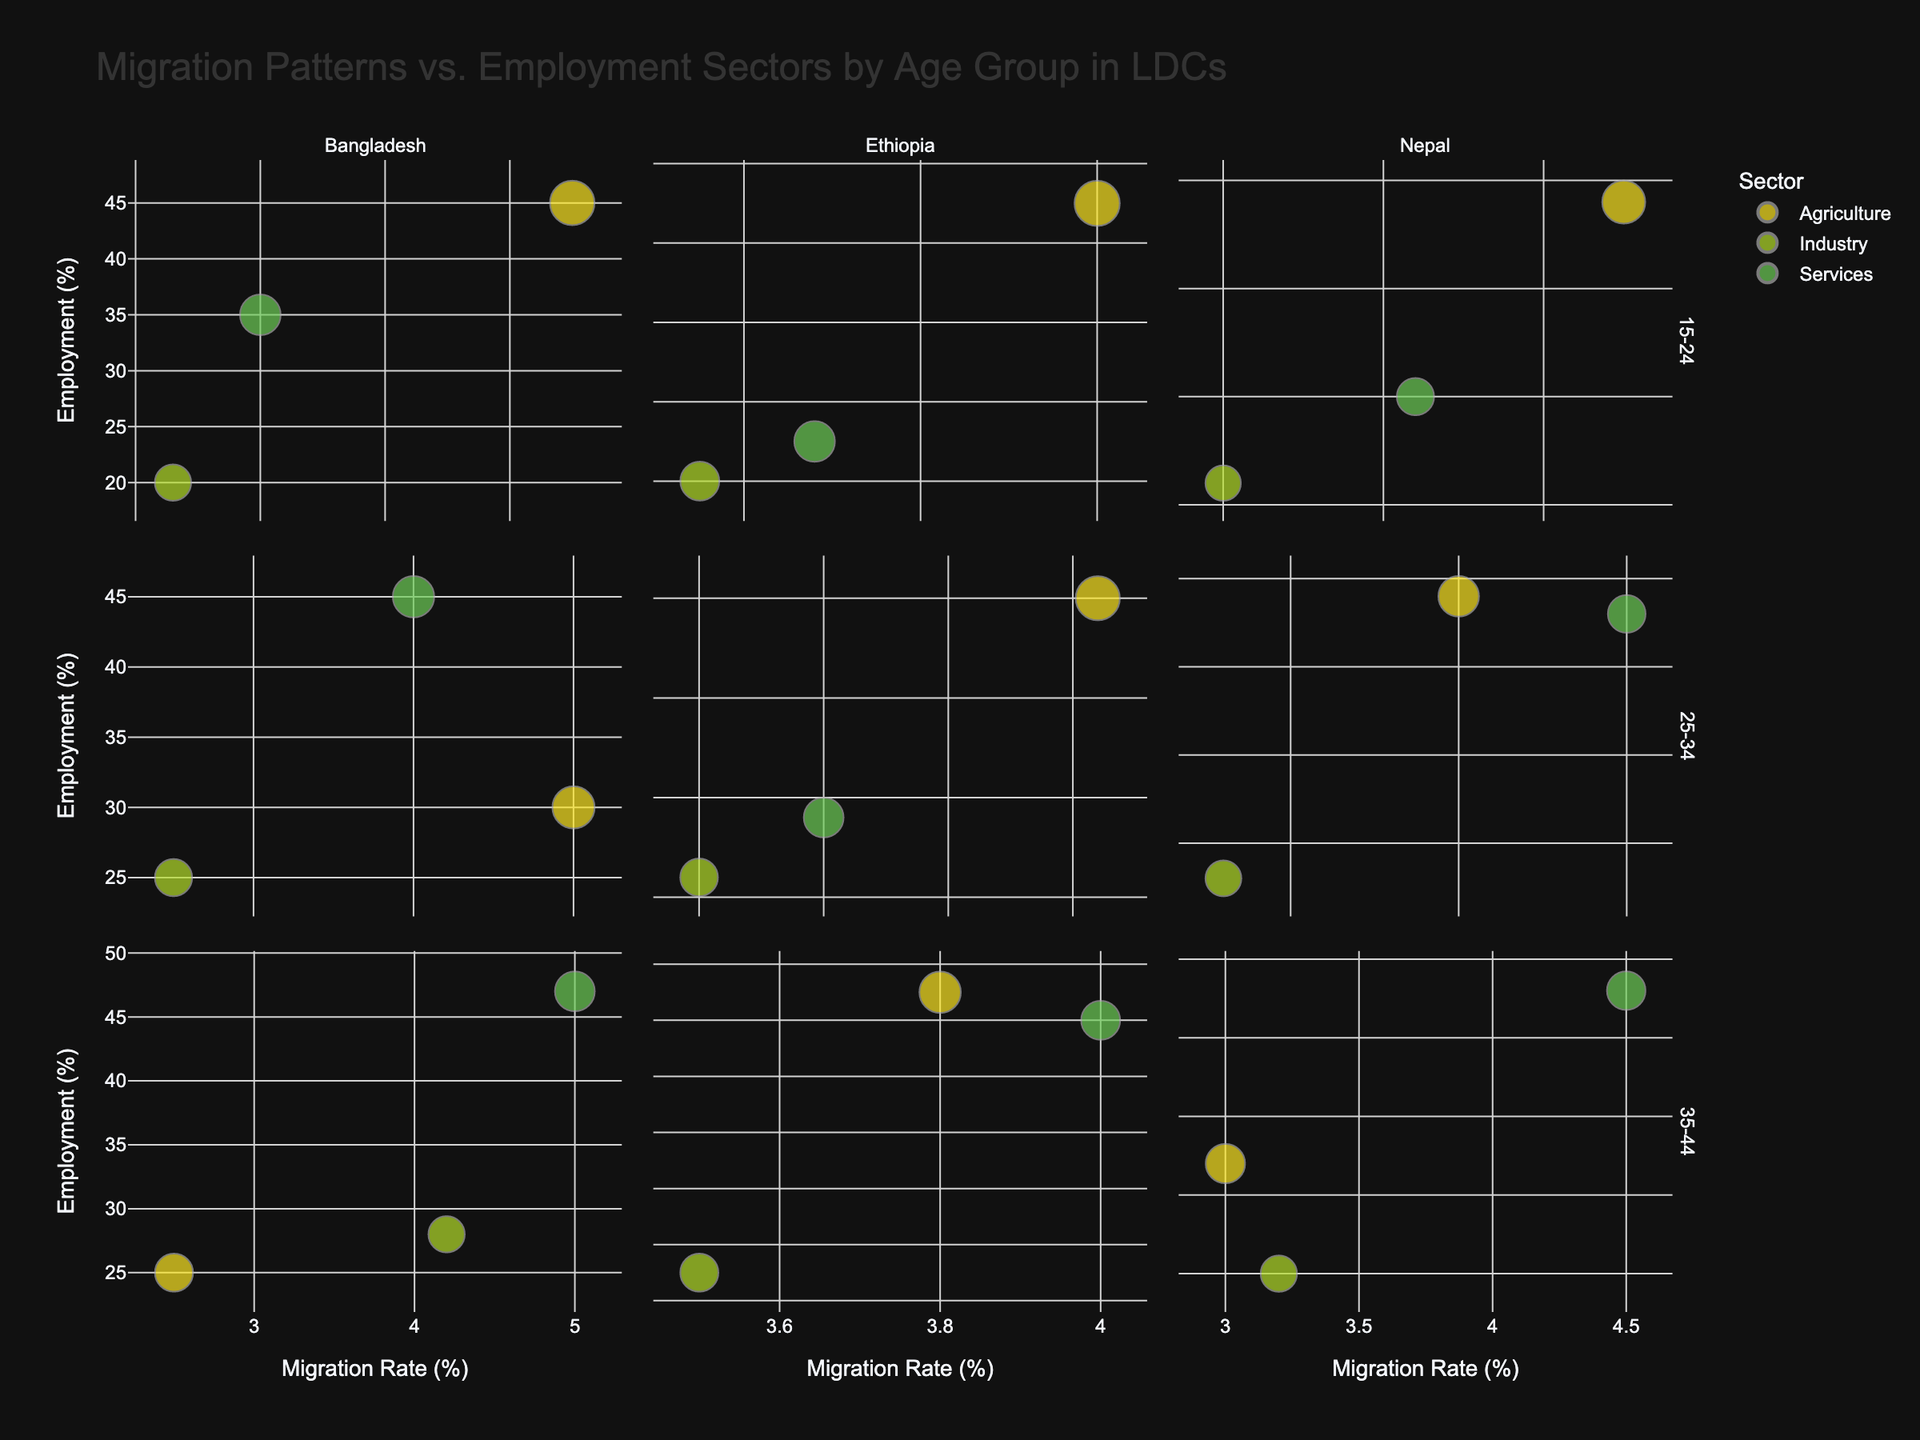What's the title of the figure? The title is positioned at the top of the figure, providing an overview of the information represented in the chart.
Answer: Migration Patterns vs. Employment Sectors by Age Group in LDCs How many countries are compared in the figure? By looking at the facet columns, each facet represents a different country.
Answer: 3 Which country shows the highest migration rate for the 15-24 age group in the agriculture sector? Identify the migration rate for the 15-24 age group in the agriculture sector across all countries and compare the values.
Answer: Ethiopia Between the 25-34 age group, which sector in Nepal shows the highest employment percentage? Look at the bubbles under the Nepal facet for the 25-34 age group and compare the employment percentages for each sector.
Answer: Services What is the migration rate for Bangladesh in the Industry sector for the 35-44 age group? Locate the Bangladesh facet, find the 35-44 age group, and identify the migration rate in the Industry sector.
Answer: 4.2% Which age group in Ethiopia has the lowest migration rate in the Services sector? Check the bubbles for the Services sector in the Ethiopia facet and identify the age group with the lowest migration rate.
Answer: 15-24 How do the sizes of bubbles vary for the employment sectors in the 15-24 age group in Bangladesh? Examine the bubble sizes under the Bangladesh facet for the 15-24 age group and compare between the Agriculture, Industry, and Services sectors.
Answer: Agriculture > Services > Industry In the 25-34 age group, which country and sector combination has the highest migration rate? Compare the migration rates for the 25-34 age group across all countries and sectors to identify the highest value.
Answer: Ethiopia, Agriculture What's the average employment percentage across all sectors for the 35-44 age group in Nepal? Sum the employment percentages for all sectors in the 35-44 age group in Nepal and divide by the number of sectors.
Answer: (32 + 25 + 43) / 3 = 33.33 Which sector in Ethiopia shows the most even distribution of employment percentages across all age groups? Observe the bubbles for Ethiopia's three sectors and the employment percentages across the age groups to determine which one varies the least.
Answer: Services 